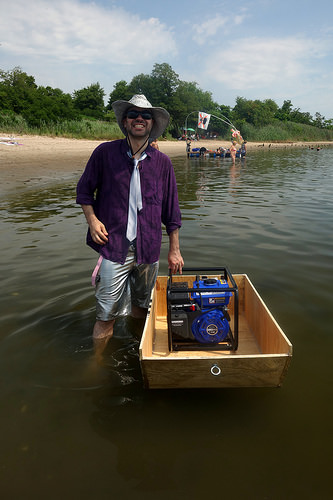<image>
Can you confirm if the necktie is on the silver shorts? No. The necktie is not positioned on the silver shorts. They may be near each other, but the necktie is not supported by or resting on top of the silver shorts. Is the crate in the water? Yes. The crate is contained within or inside the water, showing a containment relationship. 